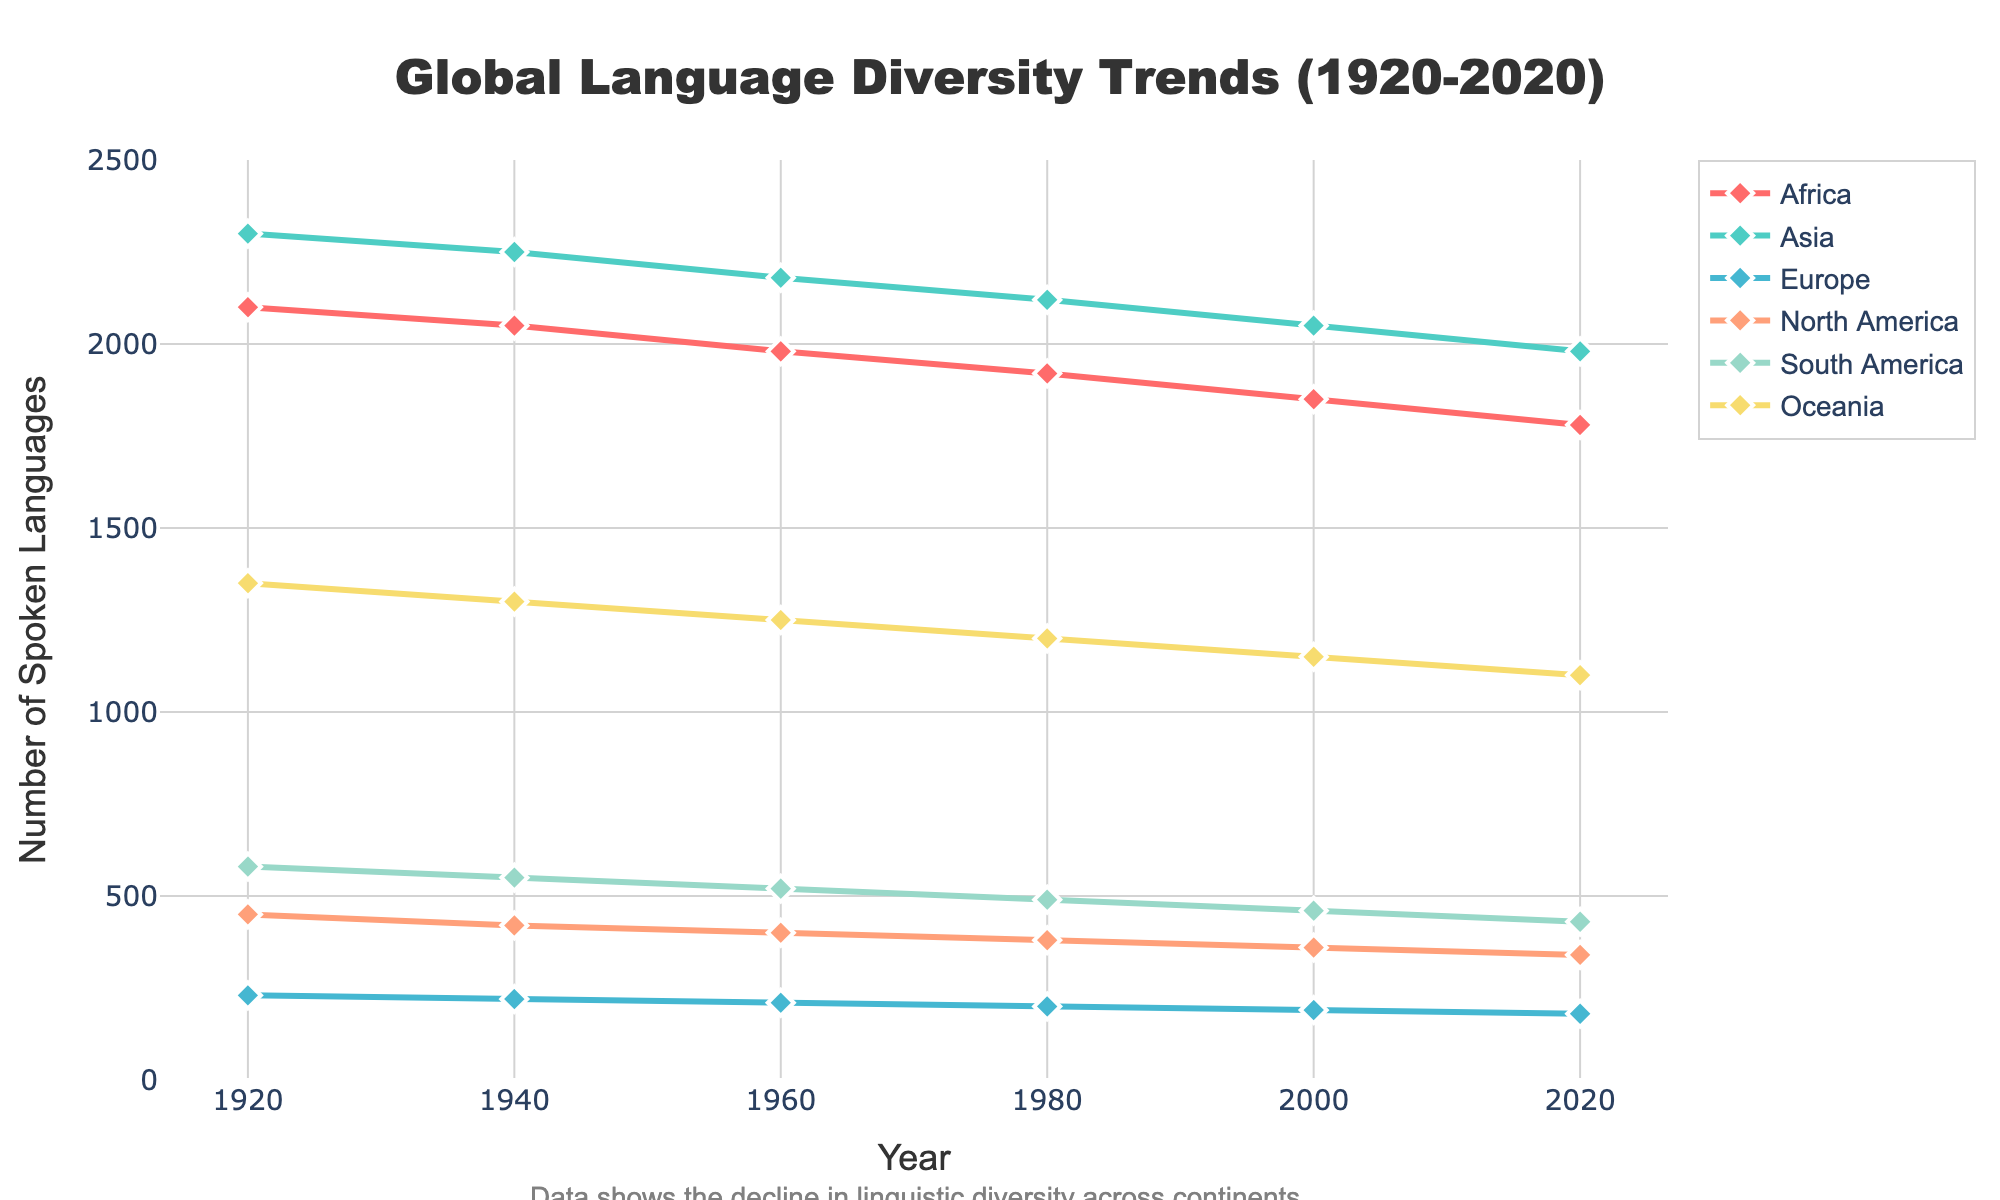What year did Africa have the highest number of spoken languages? By observing the y-axis values for Africa's line in the graph and tracing it back to the corresponding x-axis, we can see that Africa had the highest number of spoken languages in 1920.
Answer: 1920 Which continent showed the least decline in spoken languages from 1920 to 2020? Calculate the decline for each continent by subtracting the number of spoken languages in 2020 from that in 1920, and compare these values. Europe’s decline is the smallest as it only dropped by 50 (230 - 180).
Answer: Europe In 1960, which two continents had the closest number of spoken languages? By observing the values for 1960 on the y-axis, we see that South America (520) and Oceania (1250) appear closest in numbers when comparing the differences between other pairs.
Answer: South America and Oceania What is the average number of spoken languages in Asia over the given years? Add up the numbers for Asia across all years (2300 + 2250 + 2180 + 2120 + 2050 + 1980 = 12880), then divide by the number of years (6).
Answer: 2146.67 How many more languages were spoken in Africa than in Europe in 1940? Subtract the number of languages in Europe from that in Africa in 1940 (2050 - 220).
Answer: 1830 Which continent’s line uses a green color in the graph? Observe the colors used for each continent’s line; the green line corresponds to Asia.
Answer: Asia Which continent had a consistent downward trend in the number of spoken languages across all years? By observing the trend lines, Africa consistently declines from 2100 in 1920 to 1780 in 2020.
Answer: Africa What was the difference in the number of spoken languages between the Americas (North and South) in 1920? Subtract the number of languages in North America from South America in 1920 (580 - 450).
Answer: 130 Which year exhibited the largest gap between the number of spoken languages in Africa and Oceania? Calculate the difference between Africa and Oceania for each year and identify the year with the maximum gap. 1920 shows the largest gap of 750 (2100 - 1350).
Answer: 1920 